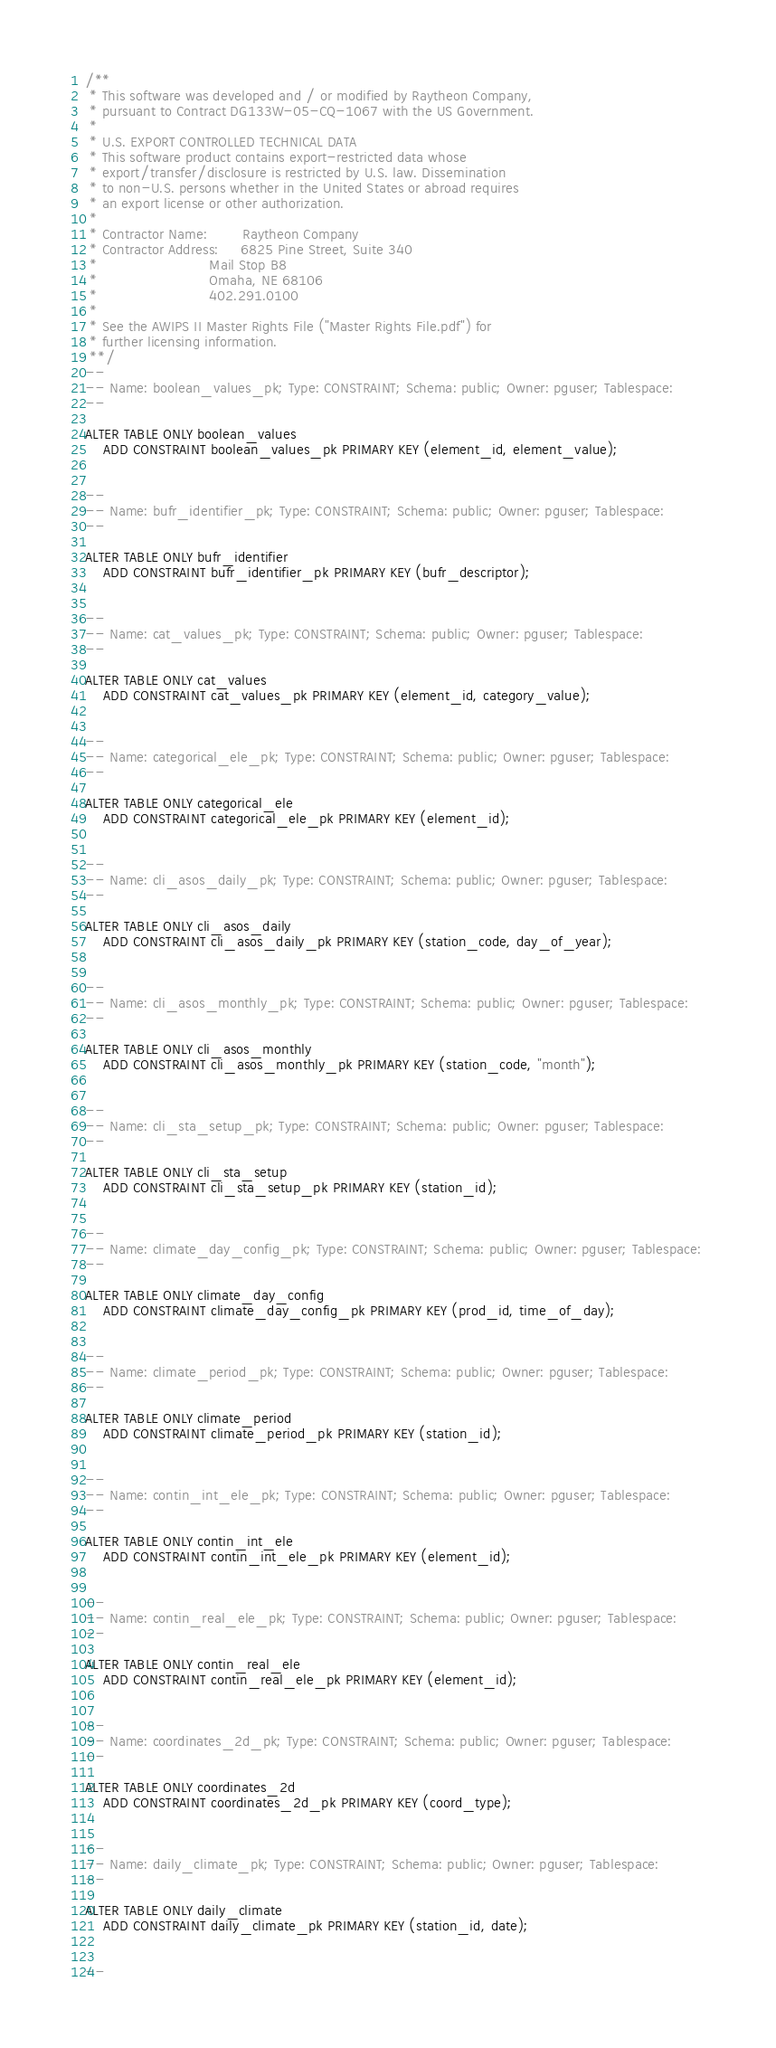<code> <loc_0><loc_0><loc_500><loc_500><_SQL_>/**
 * This software was developed and / or modified by Raytheon Company,
 * pursuant to Contract DG133W-05-CQ-1067 with the US Government.
 * 
 * U.S. EXPORT CONTROLLED TECHNICAL DATA
 * This software product contains export-restricted data whose
 * export/transfer/disclosure is restricted by U.S. law. Dissemination
 * to non-U.S. persons whether in the United States or abroad requires
 * an export license or other authorization.
 * 
 * Contractor Name:        Raytheon Company
 * Contractor Address:     6825 Pine Street, Suite 340
 *                         Mail Stop B8
 *                         Omaha, NE 68106
 *                         402.291.0100
 * 
 * See the AWIPS II Master Rights File ("Master Rights File.pdf") for
 * further licensing information.
 **/
--
-- Name: boolean_values_pk; Type: CONSTRAINT; Schema: public; Owner: pguser; Tablespace: 
--

ALTER TABLE ONLY boolean_values
    ADD CONSTRAINT boolean_values_pk PRIMARY KEY (element_id, element_value);


--
-- Name: bufr_identifier_pk; Type: CONSTRAINT; Schema: public; Owner: pguser; Tablespace: 
--

ALTER TABLE ONLY bufr_identifier
    ADD CONSTRAINT bufr_identifier_pk PRIMARY KEY (bufr_descriptor);


--
-- Name: cat_values_pk; Type: CONSTRAINT; Schema: public; Owner: pguser; Tablespace: 
--

ALTER TABLE ONLY cat_values
    ADD CONSTRAINT cat_values_pk PRIMARY KEY (element_id, category_value);


--
-- Name: categorical_ele_pk; Type: CONSTRAINT; Schema: public; Owner: pguser; Tablespace: 
--

ALTER TABLE ONLY categorical_ele
    ADD CONSTRAINT categorical_ele_pk PRIMARY KEY (element_id);


--
-- Name: cli_asos_daily_pk; Type: CONSTRAINT; Schema: public; Owner: pguser; Tablespace: 
--

ALTER TABLE ONLY cli_asos_daily
    ADD CONSTRAINT cli_asos_daily_pk PRIMARY KEY (station_code, day_of_year);


--
-- Name: cli_asos_monthly_pk; Type: CONSTRAINT; Schema: public; Owner: pguser; Tablespace: 
--

ALTER TABLE ONLY cli_asos_monthly
    ADD CONSTRAINT cli_asos_monthly_pk PRIMARY KEY (station_code, "month");


--
-- Name: cli_sta_setup_pk; Type: CONSTRAINT; Schema: public; Owner: pguser; Tablespace: 
--

ALTER TABLE ONLY cli_sta_setup
    ADD CONSTRAINT cli_sta_setup_pk PRIMARY KEY (station_id);


--
-- Name: climate_day_config_pk; Type: CONSTRAINT; Schema: public; Owner: pguser; Tablespace: 
--

ALTER TABLE ONLY climate_day_config
    ADD CONSTRAINT climate_day_config_pk PRIMARY KEY (prod_id, time_of_day);


--
-- Name: climate_period_pk; Type: CONSTRAINT; Schema: public; Owner: pguser; Tablespace: 
--

ALTER TABLE ONLY climate_period
    ADD CONSTRAINT climate_period_pk PRIMARY KEY (station_id);


--
-- Name: contin_int_ele_pk; Type: CONSTRAINT; Schema: public; Owner: pguser; Tablespace: 
--

ALTER TABLE ONLY contin_int_ele
    ADD CONSTRAINT contin_int_ele_pk PRIMARY KEY (element_id);


--
-- Name: contin_real_ele_pk; Type: CONSTRAINT; Schema: public; Owner: pguser; Tablespace: 
--

ALTER TABLE ONLY contin_real_ele
    ADD CONSTRAINT contin_real_ele_pk PRIMARY KEY (element_id);


--
-- Name: coordinates_2d_pk; Type: CONSTRAINT; Schema: public; Owner: pguser; Tablespace: 
--

ALTER TABLE ONLY coordinates_2d
    ADD CONSTRAINT coordinates_2d_pk PRIMARY KEY (coord_type);


--
-- Name: daily_climate_pk; Type: CONSTRAINT; Schema: public; Owner: pguser; Tablespace: 
--

ALTER TABLE ONLY daily_climate
    ADD CONSTRAINT daily_climate_pk PRIMARY KEY (station_id, date);


--</code> 